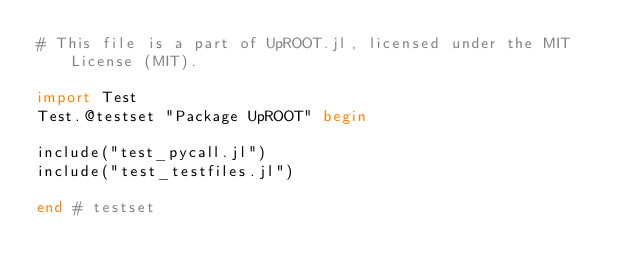Convert code to text. <code><loc_0><loc_0><loc_500><loc_500><_Julia_># This file is a part of UpROOT.jl, licensed under the MIT License (MIT).

import Test
Test.@testset "Package UpROOT" begin

include("test_pycall.jl")
include("test_testfiles.jl")

end # testset
</code> 